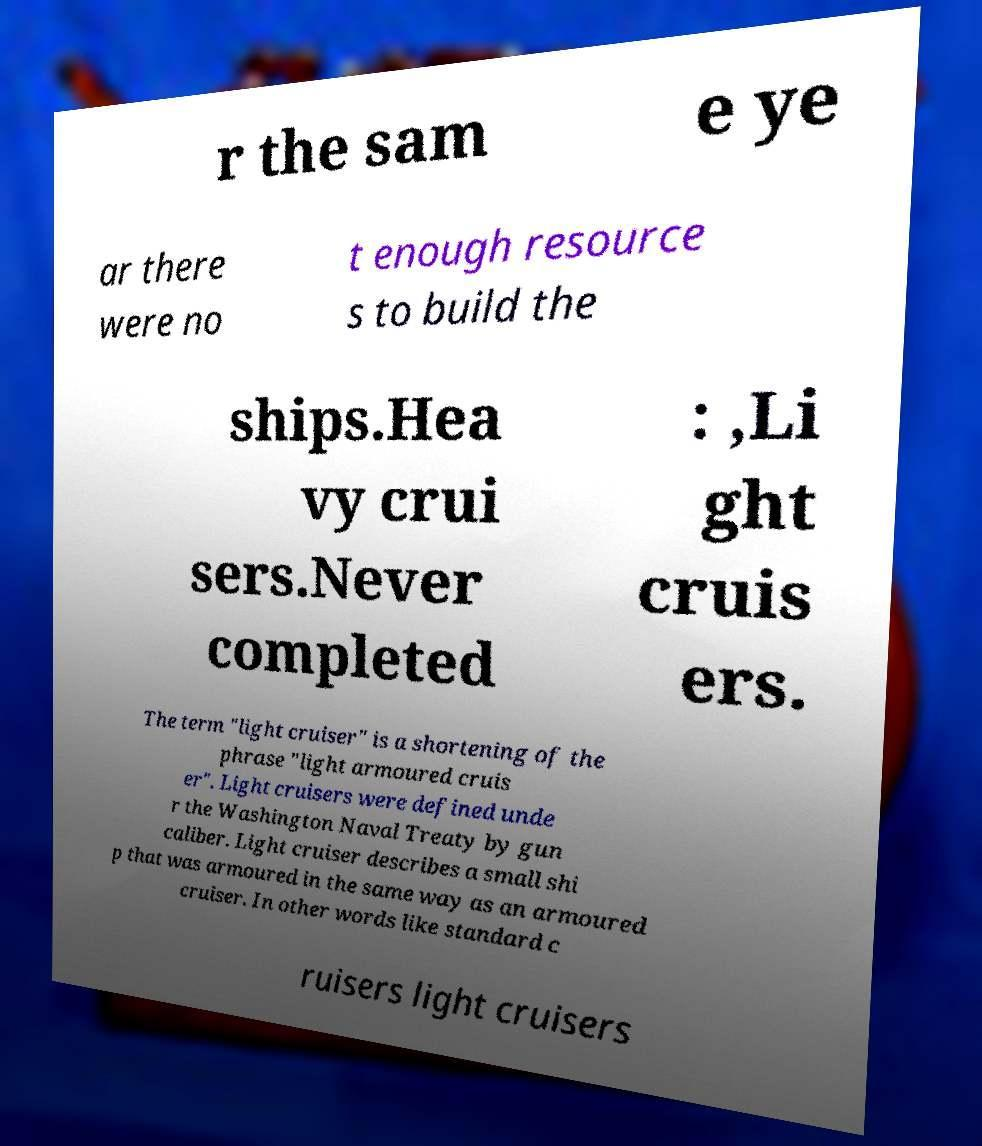Can you accurately transcribe the text from the provided image for me? r the sam e ye ar there were no t enough resource s to build the ships.Hea vy crui sers.Never completed : ,Li ght cruis ers. The term "light cruiser" is a shortening of the phrase "light armoured cruis er". Light cruisers were defined unde r the Washington Naval Treaty by gun caliber. Light cruiser describes a small shi p that was armoured in the same way as an armoured cruiser. In other words like standard c ruisers light cruisers 